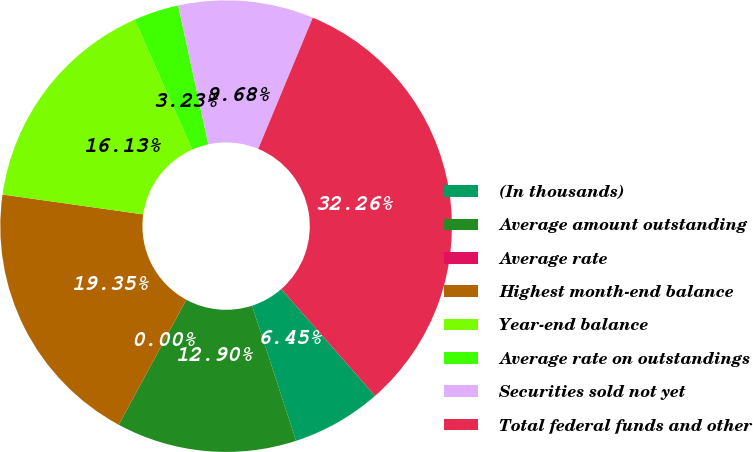Convert chart to OTSL. <chart><loc_0><loc_0><loc_500><loc_500><pie_chart><fcel>(In thousands)<fcel>Average amount outstanding<fcel>Average rate<fcel>Highest month-end balance<fcel>Year-end balance<fcel>Average rate on outstandings<fcel>Securities sold not yet<fcel>Total federal funds and other<nl><fcel>6.45%<fcel>12.9%<fcel>0.0%<fcel>19.35%<fcel>16.13%<fcel>3.23%<fcel>9.68%<fcel>32.26%<nl></chart> 